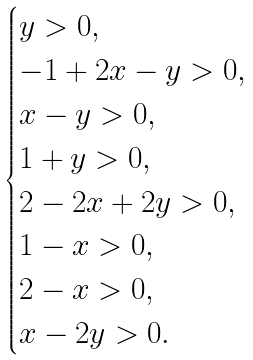<formula> <loc_0><loc_0><loc_500><loc_500>\begin{cases} y > 0 , \\ - 1 + 2 x - y > 0 , \\ x - y > 0 , \\ 1 + y > 0 , \\ 2 - 2 x + 2 y > 0 , \\ 1 - x > 0 , \\ 2 - x > 0 , \\ x - 2 y > 0 . \end{cases}</formula> 